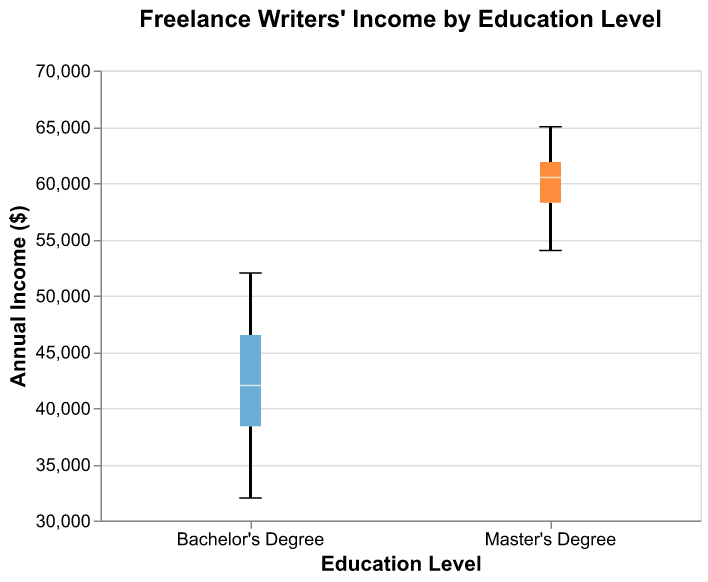What is the title of the figure? The title of the figure is displayed at the top and it reads "Freelance Writers' Income by Education Level".
Answer: Freelance Writers' Income by Education Level Which education level has the higher median income? By observing the position of the white lines (medians) inside each box, the median line for "Master's Degree" is higher than the one for "Bachelor's Degree".
Answer: Master's Degree What is the income range for writers with a Bachelor's Degree? The minimum value of the whisker (at the bottom) is $32,000, and the maximum value of the whisker (at the top) is $52,000.
Answer: $32,000 to $52,000 Which group shows a greater spread in income values? By comparing the length of the boxes and whiskers, the spread for "Master's Degree" is larger as it ranges from $54,000 to $65,000 compared to "Bachelor's Degree" which ranges from $32,000 to $52,000.
Answer: Master's Degree What is the difference between the maximum incomes of both education levels? The maximum income for "Bachelor's Degree" is $52,000 and for "Master's Degree" is $65,000. The difference would be $65,000 - $52,000.
Answer: $13,000 What is the mean income for writers with a Master's Degree? To find the mean, sum all the incomes for "Master's Degree" and divide by the number of data points. The sum is $600,000 and there are 10 data points; $600,000/10 equals $60,000.
Answer: $60,000 Is there any overlap in income ranges between the two education levels? By observing the whiskers, we see that the upper whisker of the "Bachelor's Degree" ends below $54,000, which is the starting point of the "Master's Degree" range. Hence, there's no overlap.
Answer: No How does the interquartile range (IQR) of Bachelor's Degree compare to Master's Degree? The IQR is the distance between the first and third quartiles (box edges). The IQR for "Bachelor’s Degree" visually appears smaller than that for "Master’s Degree", indicating a narrower income spread between the middle 50% of data.
Answer: Smaller What is the lowest income observed for writers with a Master's Degree? The bottom whisker for "Master's Degree" reaches down to $54,000, indicating the lowest income.
Answer: $54,000 